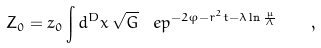Convert formula to latex. <formula><loc_0><loc_0><loc_500><loc_500>Z _ { 0 } = z _ { 0 } \int d ^ { D } x \, \sqrt { G } \, \ e p ^ { - 2 \varphi - r ^ { 2 } t - \lambda \ln \frac { \mu } { \Lambda } } \quad ,</formula> 